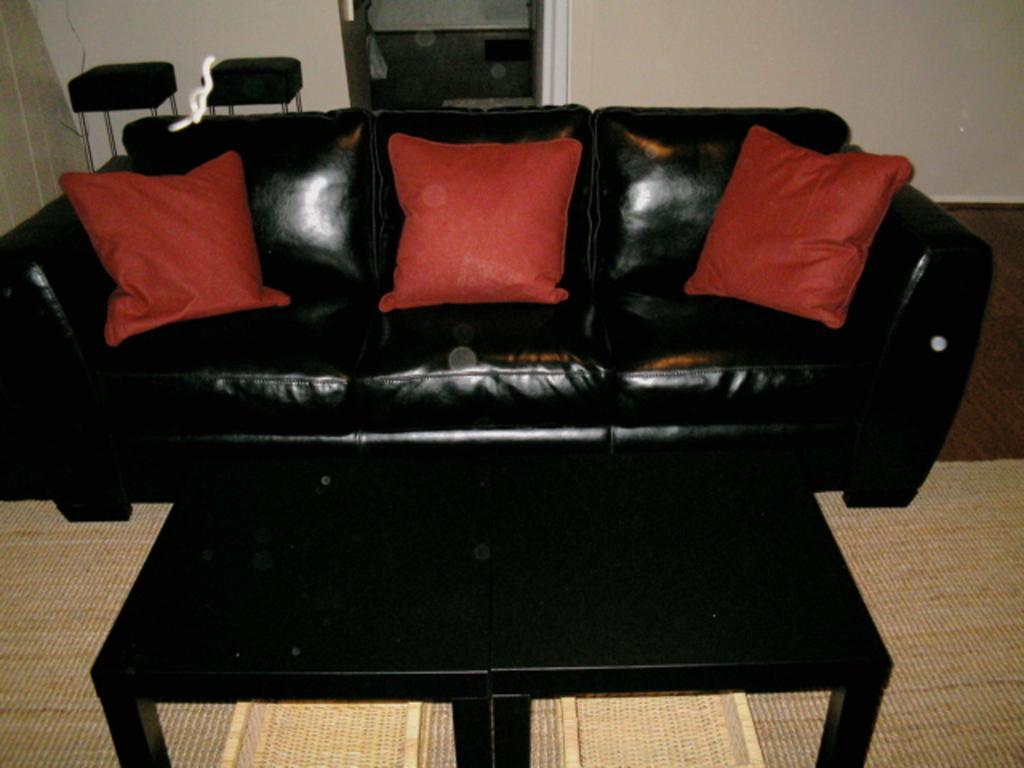How would you summarize this image in a sentence or two? In this image we can see a table, black color sofa with red color pillows, two stools and the wall in the background. 